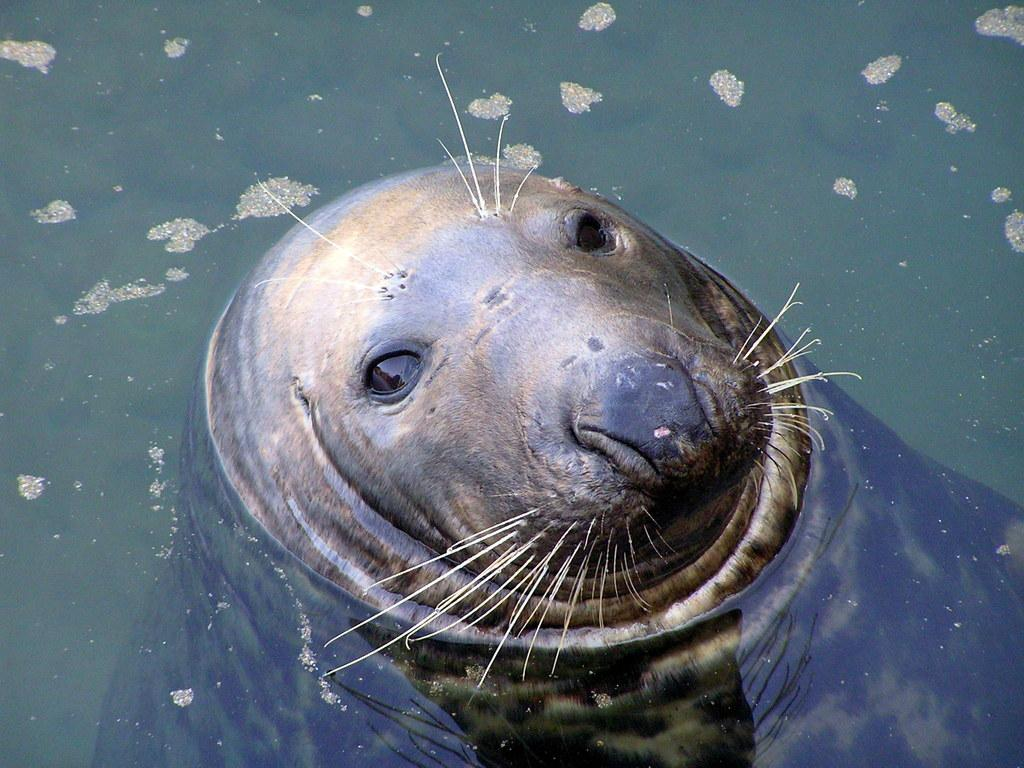What animal is in the center of the image? There is a seal in the center of the image. Where is the seal located? The seal is in the water. What can be seen around the area of the image? There is water visible around the area of the image. What type of ball is the seal playing with in the image? There is no ball present in the image; the seal is simply in the water. What hobbies does the town depicted in the image have? There is no town present in the image, so it is not possible to determine the hobbies of any town. 